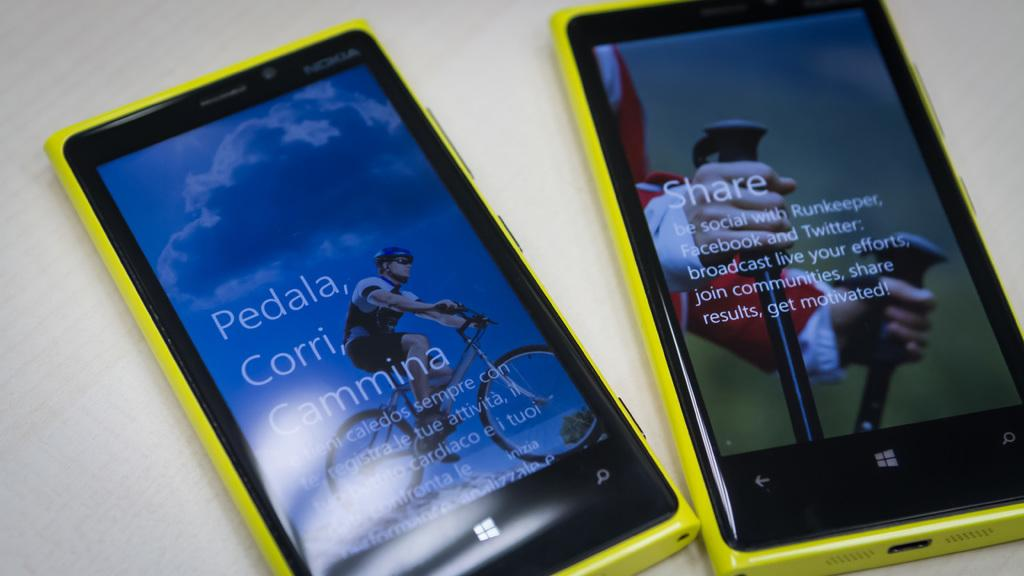<image>
Provide a brief description of the given image. A couple of cell phones display Share and other words on their screens. 